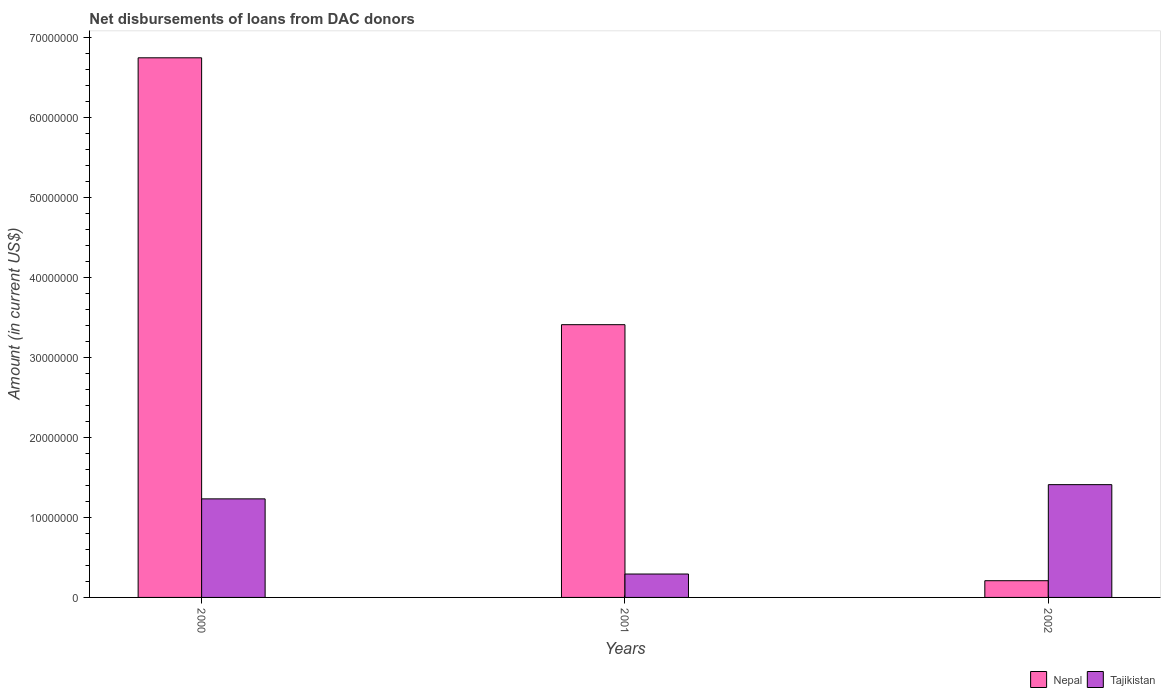Are the number of bars on each tick of the X-axis equal?
Your answer should be very brief. Yes. How many bars are there on the 3rd tick from the left?
Your answer should be very brief. 2. How many bars are there on the 3rd tick from the right?
Provide a short and direct response. 2. What is the amount of loans disbursed in Nepal in 2000?
Make the answer very short. 6.75e+07. Across all years, what is the maximum amount of loans disbursed in Tajikistan?
Your answer should be compact. 1.41e+07. Across all years, what is the minimum amount of loans disbursed in Nepal?
Provide a succinct answer. 2.09e+06. What is the total amount of loans disbursed in Tajikistan in the graph?
Your response must be concise. 2.94e+07. What is the difference between the amount of loans disbursed in Tajikistan in 2000 and that in 2002?
Provide a short and direct response. -1.78e+06. What is the difference between the amount of loans disbursed in Tajikistan in 2001 and the amount of loans disbursed in Nepal in 2002?
Make the answer very short. 8.36e+05. What is the average amount of loans disbursed in Nepal per year?
Keep it short and to the point. 3.46e+07. In the year 2000, what is the difference between the amount of loans disbursed in Nepal and amount of loans disbursed in Tajikistan?
Ensure brevity in your answer.  5.51e+07. In how many years, is the amount of loans disbursed in Nepal greater than 34000000 US$?
Offer a very short reply. 2. What is the ratio of the amount of loans disbursed in Nepal in 2000 to that in 2001?
Your answer should be compact. 1.98. What is the difference between the highest and the second highest amount of loans disbursed in Tajikistan?
Your response must be concise. 1.78e+06. What is the difference between the highest and the lowest amount of loans disbursed in Tajikistan?
Offer a very short reply. 1.12e+07. What does the 2nd bar from the left in 2001 represents?
Give a very brief answer. Tajikistan. What does the 2nd bar from the right in 2000 represents?
Your response must be concise. Nepal. Are all the bars in the graph horizontal?
Offer a very short reply. No. What is the title of the graph?
Give a very brief answer. Net disbursements of loans from DAC donors. Does "High income: OECD" appear as one of the legend labels in the graph?
Make the answer very short. No. What is the label or title of the X-axis?
Your answer should be very brief. Years. What is the label or title of the Y-axis?
Give a very brief answer. Amount (in current US$). What is the Amount (in current US$) of Nepal in 2000?
Provide a short and direct response. 6.75e+07. What is the Amount (in current US$) in Tajikistan in 2000?
Provide a short and direct response. 1.23e+07. What is the Amount (in current US$) in Nepal in 2001?
Make the answer very short. 3.41e+07. What is the Amount (in current US$) of Tajikistan in 2001?
Offer a terse response. 2.93e+06. What is the Amount (in current US$) in Nepal in 2002?
Offer a very short reply. 2.09e+06. What is the Amount (in current US$) of Tajikistan in 2002?
Make the answer very short. 1.41e+07. Across all years, what is the maximum Amount (in current US$) in Nepal?
Provide a short and direct response. 6.75e+07. Across all years, what is the maximum Amount (in current US$) in Tajikistan?
Provide a short and direct response. 1.41e+07. Across all years, what is the minimum Amount (in current US$) in Nepal?
Your answer should be very brief. 2.09e+06. Across all years, what is the minimum Amount (in current US$) of Tajikistan?
Keep it short and to the point. 2.93e+06. What is the total Amount (in current US$) in Nepal in the graph?
Ensure brevity in your answer.  1.04e+08. What is the total Amount (in current US$) of Tajikistan in the graph?
Provide a succinct answer. 2.94e+07. What is the difference between the Amount (in current US$) of Nepal in 2000 and that in 2001?
Give a very brief answer. 3.34e+07. What is the difference between the Amount (in current US$) of Tajikistan in 2000 and that in 2001?
Offer a very short reply. 9.40e+06. What is the difference between the Amount (in current US$) in Nepal in 2000 and that in 2002?
Make the answer very short. 6.54e+07. What is the difference between the Amount (in current US$) in Tajikistan in 2000 and that in 2002?
Provide a short and direct response. -1.78e+06. What is the difference between the Amount (in current US$) in Nepal in 2001 and that in 2002?
Give a very brief answer. 3.20e+07. What is the difference between the Amount (in current US$) in Tajikistan in 2001 and that in 2002?
Provide a short and direct response. -1.12e+07. What is the difference between the Amount (in current US$) of Nepal in 2000 and the Amount (in current US$) of Tajikistan in 2001?
Provide a succinct answer. 6.45e+07. What is the difference between the Amount (in current US$) of Nepal in 2000 and the Amount (in current US$) of Tajikistan in 2002?
Your answer should be compact. 5.34e+07. What is the difference between the Amount (in current US$) of Nepal in 2001 and the Amount (in current US$) of Tajikistan in 2002?
Provide a succinct answer. 2.00e+07. What is the average Amount (in current US$) in Nepal per year?
Offer a terse response. 3.46e+07. What is the average Amount (in current US$) in Tajikistan per year?
Make the answer very short. 9.78e+06. In the year 2000, what is the difference between the Amount (in current US$) of Nepal and Amount (in current US$) of Tajikistan?
Ensure brevity in your answer.  5.51e+07. In the year 2001, what is the difference between the Amount (in current US$) of Nepal and Amount (in current US$) of Tajikistan?
Provide a short and direct response. 3.12e+07. In the year 2002, what is the difference between the Amount (in current US$) in Nepal and Amount (in current US$) in Tajikistan?
Ensure brevity in your answer.  -1.20e+07. What is the ratio of the Amount (in current US$) of Nepal in 2000 to that in 2001?
Provide a short and direct response. 1.98. What is the ratio of the Amount (in current US$) of Tajikistan in 2000 to that in 2001?
Offer a terse response. 4.21. What is the ratio of the Amount (in current US$) in Nepal in 2000 to that in 2002?
Ensure brevity in your answer.  32.28. What is the ratio of the Amount (in current US$) of Tajikistan in 2000 to that in 2002?
Offer a terse response. 0.87. What is the ratio of the Amount (in current US$) of Nepal in 2001 to that in 2002?
Make the answer very short. 16.32. What is the ratio of the Amount (in current US$) in Tajikistan in 2001 to that in 2002?
Ensure brevity in your answer.  0.21. What is the difference between the highest and the second highest Amount (in current US$) in Nepal?
Make the answer very short. 3.34e+07. What is the difference between the highest and the second highest Amount (in current US$) in Tajikistan?
Your answer should be very brief. 1.78e+06. What is the difference between the highest and the lowest Amount (in current US$) of Nepal?
Keep it short and to the point. 6.54e+07. What is the difference between the highest and the lowest Amount (in current US$) of Tajikistan?
Offer a very short reply. 1.12e+07. 